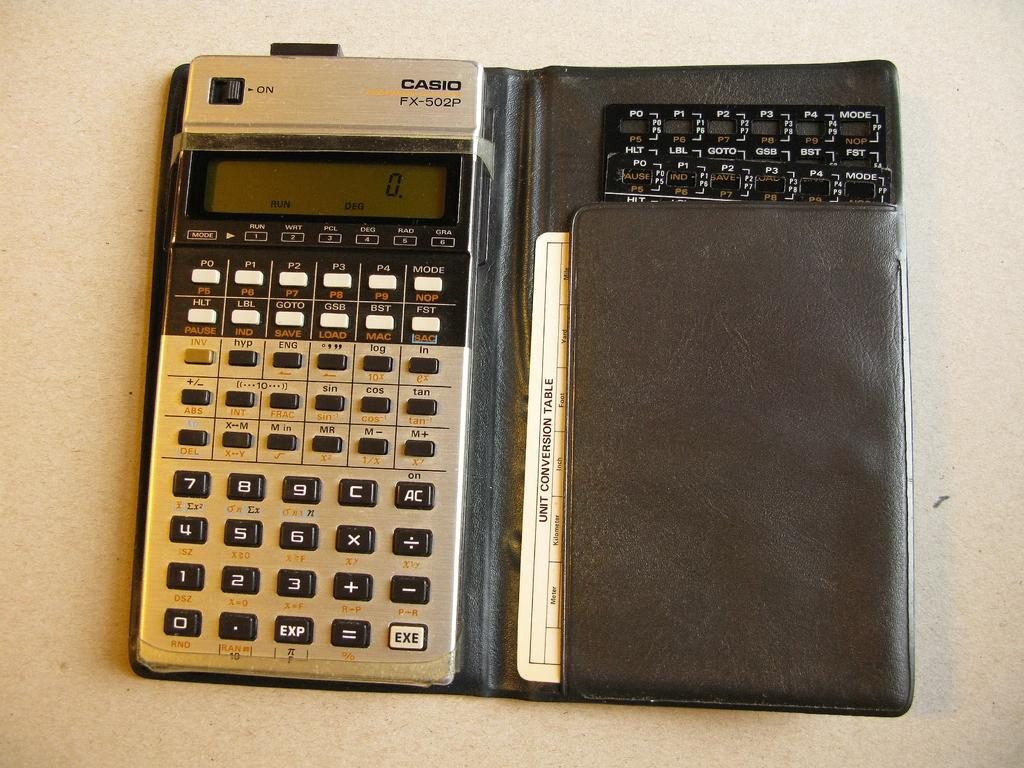<image>
Write a terse but informative summary of the picture. A Casio calculator has a card folded up in the case. 